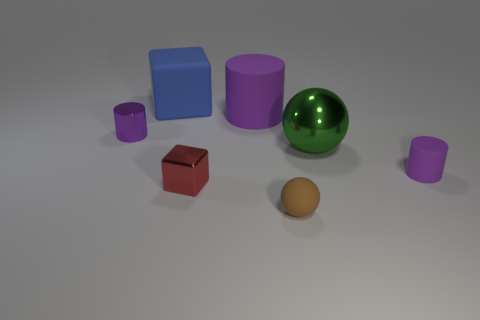The purple matte thing that is on the left side of the purple rubber thing that is in front of the big green shiny ball is what shape?
Make the answer very short. Cylinder. What number of purple objects are either small rubber cylinders or large matte blocks?
Your answer should be very brief. 1. Is there a tiny purple matte cylinder in front of the sphere behind the tiny cylinder to the right of the brown matte sphere?
Offer a very short reply. Yes. The metal object that is the same color as the big cylinder is what shape?
Offer a terse response. Cylinder. Are there any other things that have the same material as the tiny sphere?
Your answer should be very brief. Yes. How many large things are either purple objects or green balls?
Give a very brief answer. 2. Do the tiny purple thing left of the tiny matte sphere and the small brown thing have the same shape?
Make the answer very short. No. Is the number of tiny red objects less than the number of red cylinders?
Offer a very short reply. No. Are there any other things that have the same color as the small block?
Ensure brevity in your answer.  No. What is the shape of the purple thing that is to the left of the large blue rubber cube?
Provide a succinct answer. Cylinder. 